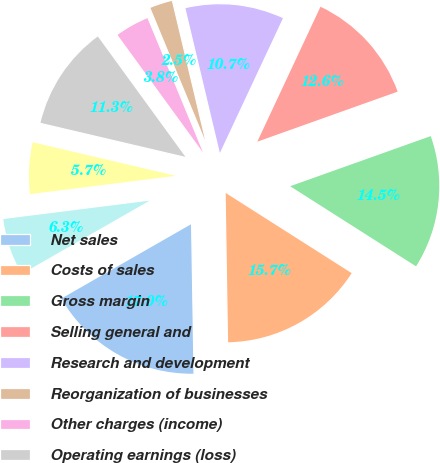Convert chart to OTSL. <chart><loc_0><loc_0><loc_500><loc_500><pie_chart><fcel>Net sales<fcel>Costs of sales<fcel>Gross margin<fcel>Selling general and<fcel>Research and development<fcel>Reorganization of businesses<fcel>Other charges (income)<fcel>Operating earnings (loss)<fcel>Interest expense net<fcel>Gains on sales of investments<nl><fcel>16.98%<fcel>15.72%<fcel>14.47%<fcel>12.58%<fcel>10.69%<fcel>2.52%<fcel>3.77%<fcel>11.32%<fcel>5.66%<fcel>6.29%<nl></chart> 